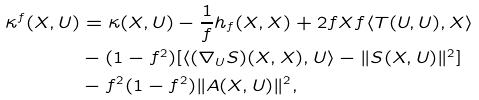Convert formula to latex. <formula><loc_0><loc_0><loc_500><loc_500>\kappa ^ { f } ( X , U ) & = \kappa ( X , U ) - \frac { 1 } { f } h _ { f } ( X , X ) + 2 f X f \langle T ( U , U ) , X \rangle \\ & - ( 1 - f ^ { 2 } ) [ \langle ( \nabla _ { U } S ) ( X , X ) , U \rangle - \| S ( X , U ) \| ^ { 2 } ] \\ & - f ^ { 2 } ( 1 - f ^ { 2 } ) \| A ( X , U ) \| ^ { 2 } ,</formula> 